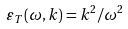<formula> <loc_0><loc_0><loc_500><loc_500>\varepsilon _ { T } ( \omega , k ) = k ^ { 2 } / \omega ^ { 2 }</formula> 